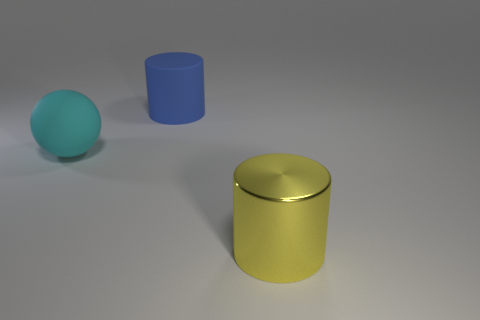What number of other things are the same color as the rubber ball?
Your answer should be very brief. 0. Is the number of tiny brown objects less than the number of big yellow cylinders?
Give a very brief answer. Yes. The rubber object behind the rubber object that is in front of the blue cylinder is what shape?
Your answer should be very brief. Cylinder. Are there any big yellow cylinders behind the cyan thing?
Ensure brevity in your answer.  No. What is the color of the cylinder that is the same size as the yellow thing?
Provide a short and direct response. Blue. How many big objects have the same material as the large yellow cylinder?
Give a very brief answer. 0. How many other objects are there of the same size as the shiny thing?
Keep it short and to the point. 2. Are there any cyan rubber spheres that have the same size as the blue thing?
Provide a succinct answer. Yes. Do the big thing that is in front of the big cyan object and the large rubber cylinder have the same color?
Offer a terse response. No. How many things are large cyan balls or big cylinders?
Ensure brevity in your answer.  3. 